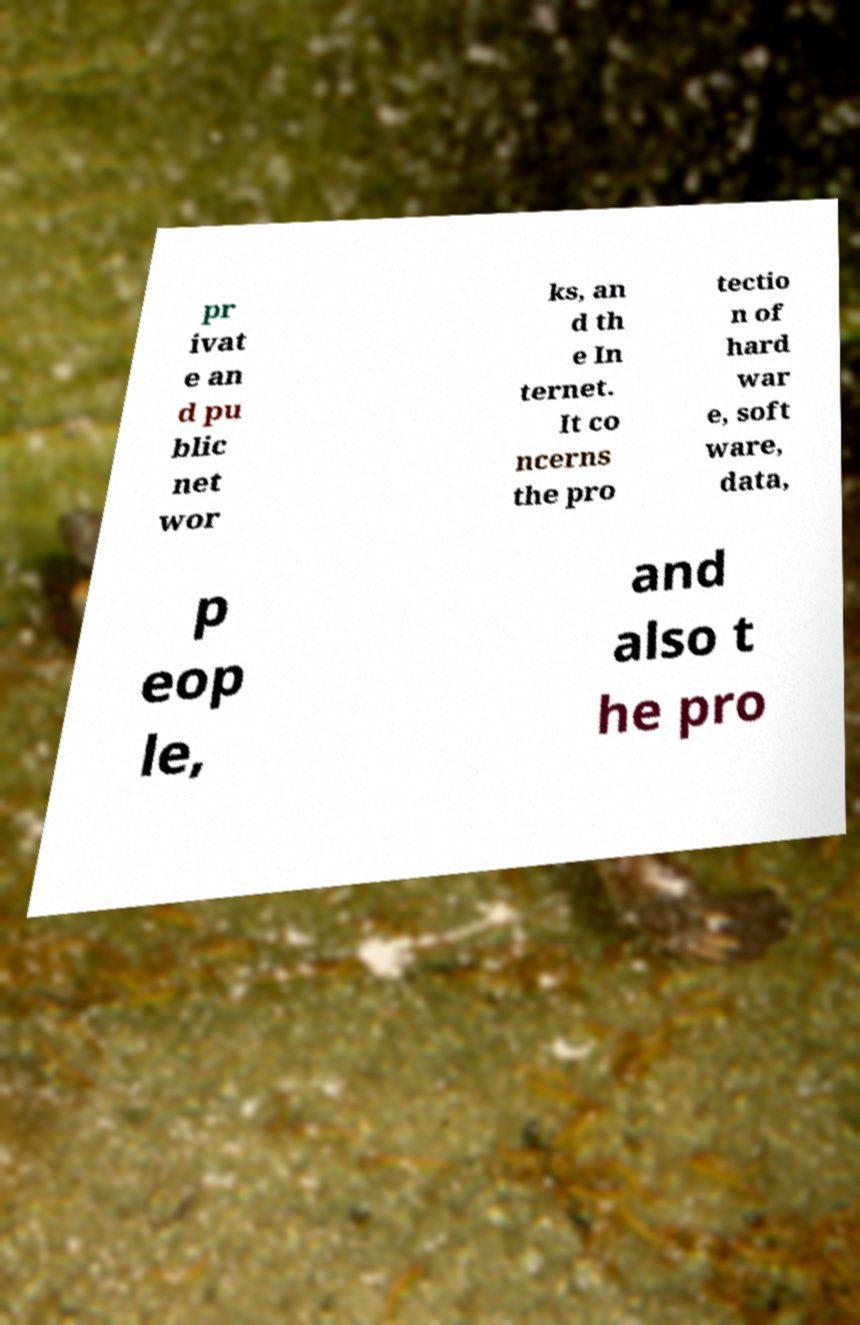Can you accurately transcribe the text from the provided image for me? pr ivat e an d pu blic net wor ks, an d th e In ternet. It co ncerns the pro tectio n of hard war e, soft ware, data, p eop le, and also t he pro 